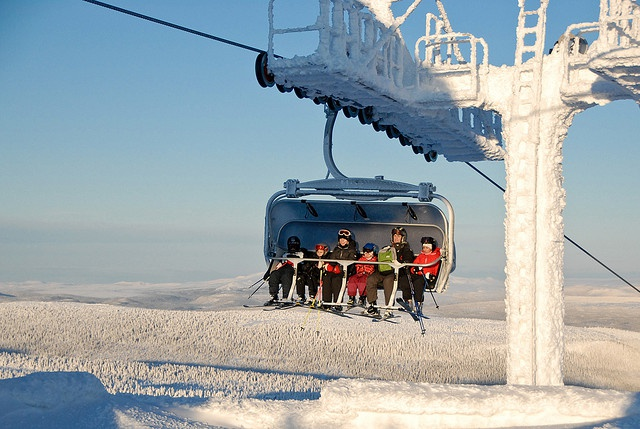Describe the objects in this image and their specific colors. I can see people in teal, black, maroon, red, and gray tones, people in teal, black, gray, darkgray, and lightgray tones, people in teal, brown, black, maroon, and red tones, people in teal, black, red, brown, and gray tones, and people in teal, black, gray, darkgray, and maroon tones in this image. 